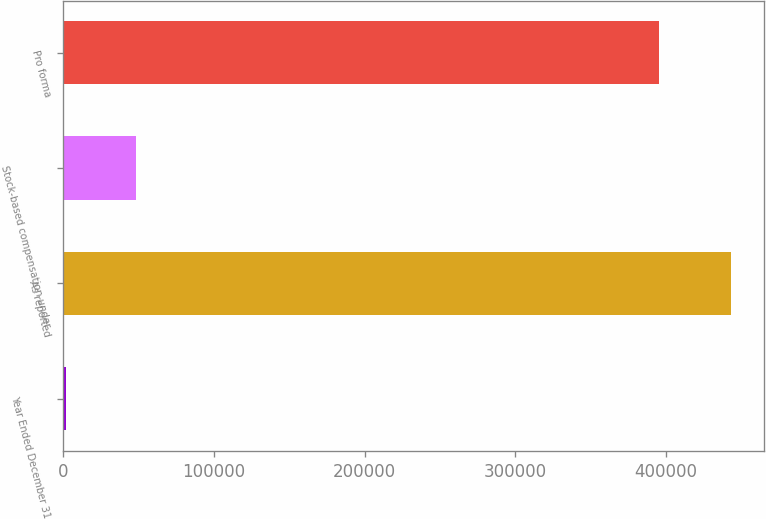Convert chart to OTSL. <chart><loc_0><loc_0><loc_500><loc_500><bar_chart><fcel>Year Ended December 31<fcel>As reported<fcel>Stock-based compensation under<fcel>Pro forma<nl><fcel>2005<fcel>443256<fcel>47934<fcel>395322<nl></chart> 